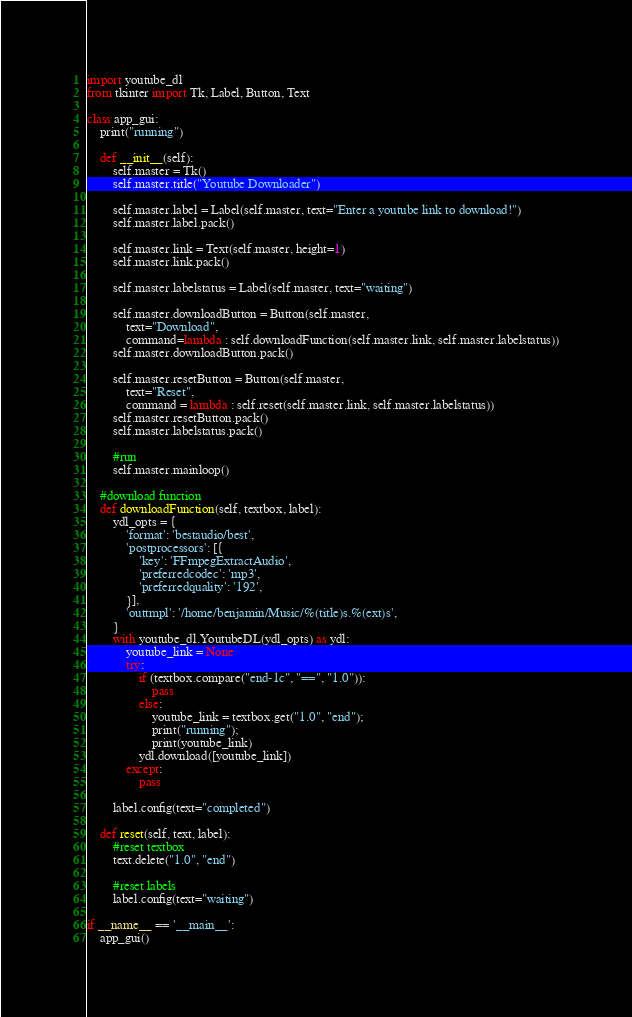Convert code to text. <code><loc_0><loc_0><loc_500><loc_500><_Python_>import youtube_dl
from tkinter import Tk, Label, Button, Text

class app_gui:
    print("running")

    def __init__(self):
        self.master = Tk()
        self.master.title("Youtube Downloader")

        self.master.label = Label(self.master, text="Enter a youtube link to download!")
        self.master.label.pack()

        self.master.link = Text(self.master, height=1)
        self.master.link.pack()

        self.master.labelstatus = Label(self.master, text="waiting")

        self.master.downloadButton = Button(self.master,
            text="Download",
            command=lambda : self.downloadFunction(self.master.link, self.master.labelstatus))
        self.master.downloadButton.pack()

        self.master.resetButton = Button(self.master,
            text="Reset",
            command = lambda : self.reset(self.master.link, self.master.labelstatus))
        self.master.resetButton.pack()
        self.master.labelstatus.pack()

        #run
        self.master.mainloop()

    #download function
    def downloadFunction(self, textbox, label):
        ydl_opts = {
            'format': 'bestaudio/best',
            'postprocessors': [{
                'key': 'FFmpegExtractAudio',
                'preferredcodec': 'mp3',
                'preferredquality': '192',
            }],
            'outtmpl': '/home/benjamin/Music/%(title)s.%(ext)s',
        }
        with youtube_dl.YoutubeDL(ydl_opts) as ydl:
            youtube_link = None
            try:
                if (textbox.compare("end-1c", "==", "1.0")):
                    pass
                else:
                    youtube_link = textbox.get("1.0", "end");
                    print("running");
                    print(youtube_link)
                ydl.download([youtube_link])
            except:
                pass

        label.config(text="completed")

    def reset(self, text, label):
        #reset textbox
        text.delete("1.0", "end")

        #reset labels
        label.config(text="waiting")

if __name__ == '__main__':
    app_gui()
</code> 